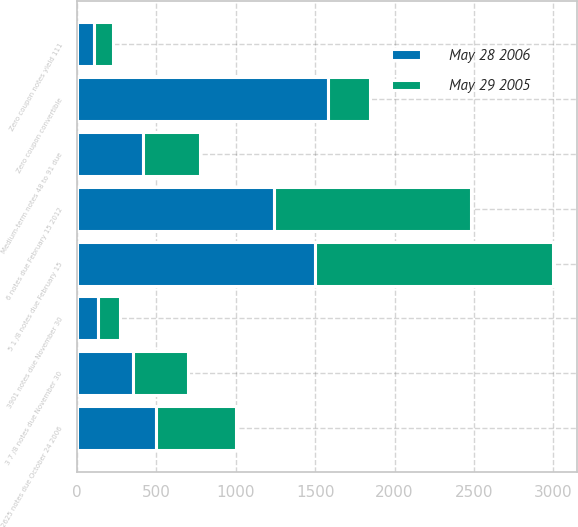<chart> <loc_0><loc_0><loc_500><loc_500><stacked_bar_chart><ecel><fcel>5 1 /8 notes due February 15<fcel>6 notes due February 15 2012<fcel>2625 notes due October 24 2006<fcel>Medium-term notes 48 to 91 due<fcel>3 7 /8 notes due November 30<fcel>Zero coupon convertible<fcel>3901 notes due November 30<fcel>Zero coupon notes yield 111<nl><fcel>May 29 2005<fcel>1500<fcel>1240<fcel>500<fcel>362<fcel>350<fcel>268<fcel>135<fcel>121<nl><fcel>May 28 2006<fcel>1500<fcel>1240<fcel>500<fcel>413<fcel>350<fcel>1579<fcel>135<fcel>108<nl></chart> 